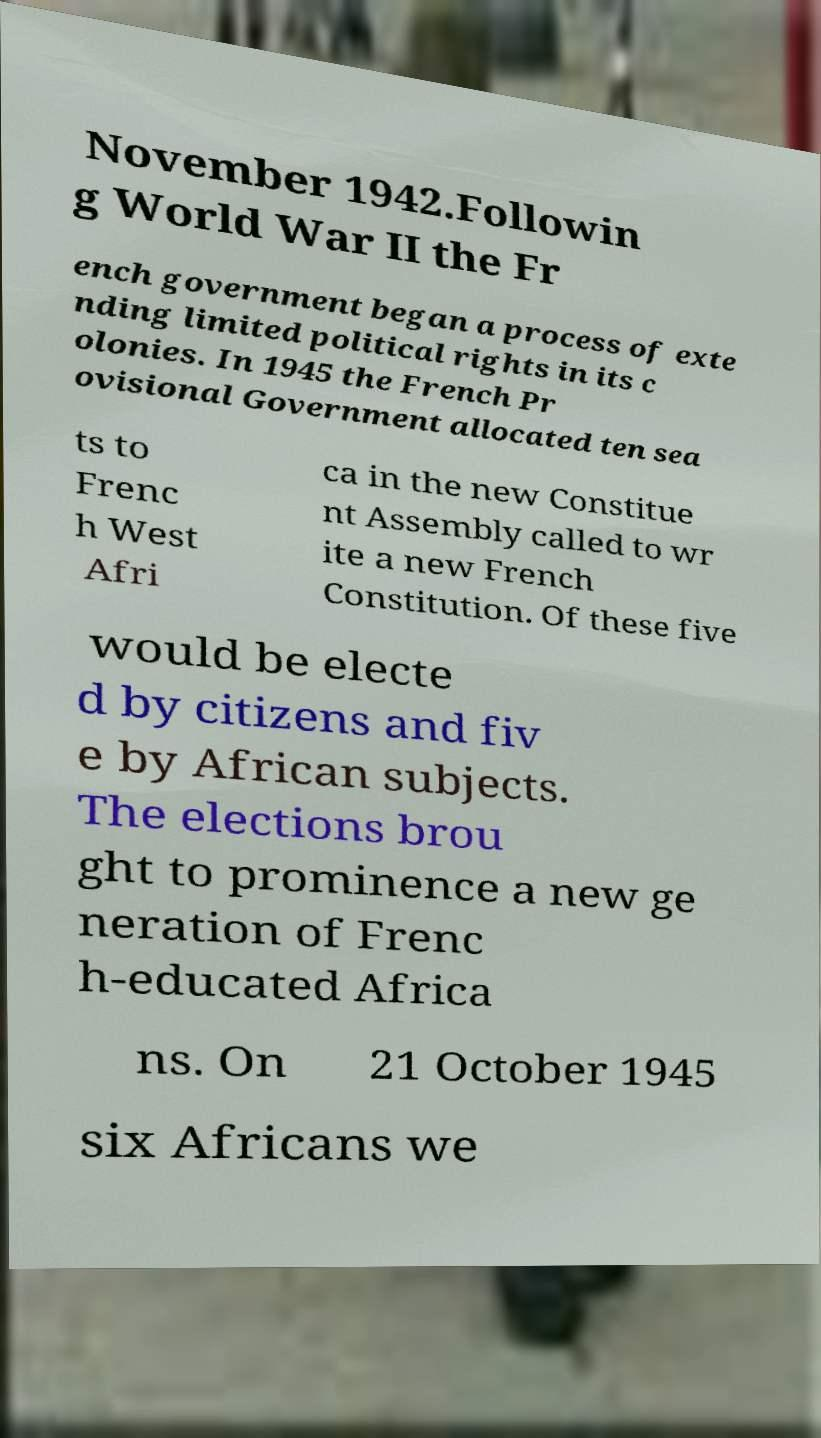For documentation purposes, I need the text within this image transcribed. Could you provide that? November 1942.Followin g World War II the Fr ench government began a process of exte nding limited political rights in its c olonies. In 1945 the French Pr ovisional Government allocated ten sea ts to Frenc h West Afri ca in the new Constitue nt Assembly called to wr ite a new French Constitution. Of these five would be electe d by citizens and fiv e by African subjects. The elections brou ght to prominence a new ge neration of Frenc h-educated Africa ns. On 21 October 1945 six Africans we 